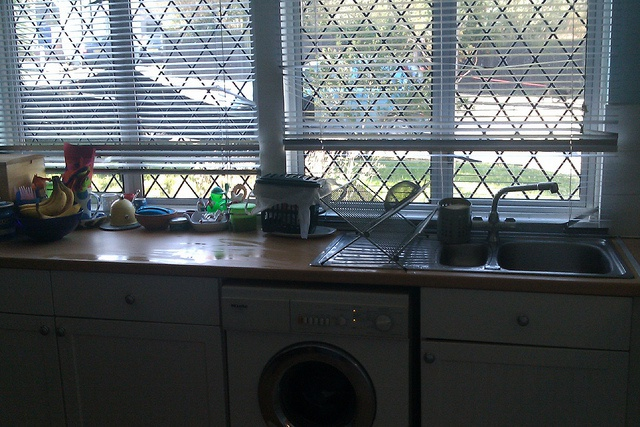Describe the objects in this image and their specific colors. I can see sink in purple, black, gray, and blue tones and banana in purple, black, darkgreen, and gray tones in this image. 